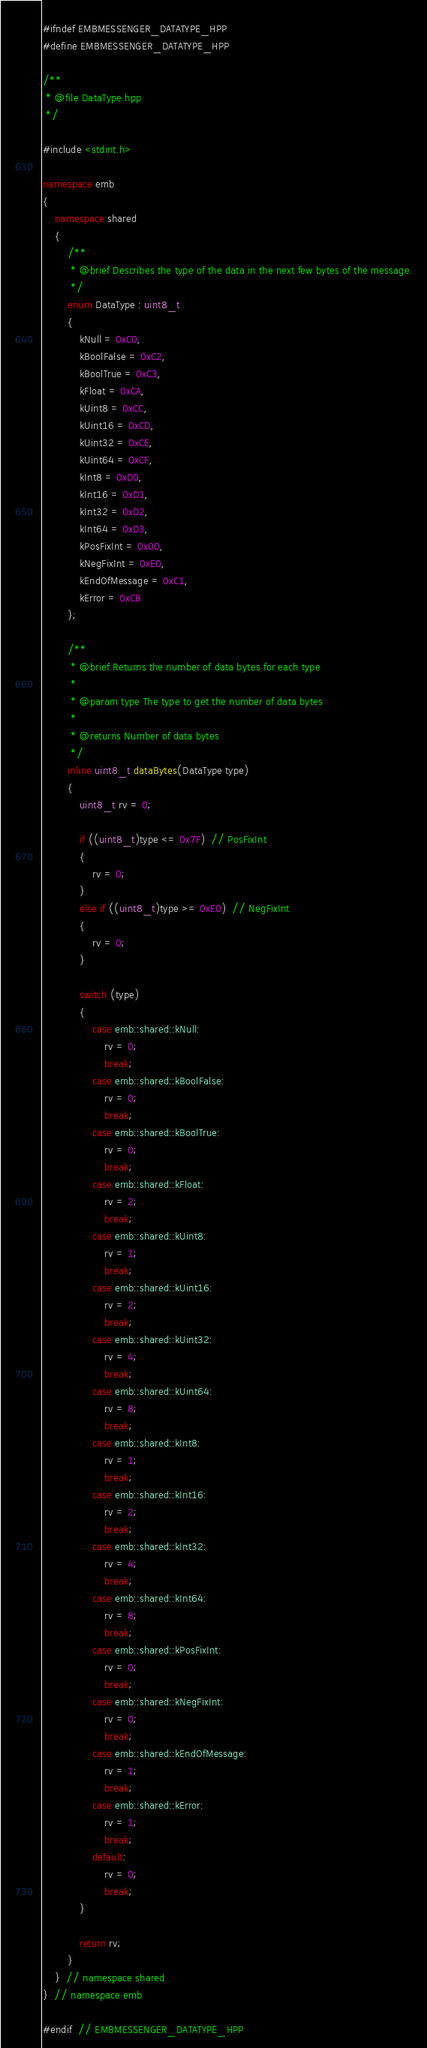<code> <loc_0><loc_0><loc_500><loc_500><_C++_>#ifndef EMBMESSENGER_DATATYPE_HPP
#define EMBMESSENGER_DATATYPE_HPP

/**
 * @file DataType.hpp
 */

#include <stdint.h>

namespace emb
{
    namespace shared
    {
        /**
         * @brief Describes the type of the data in the next few bytes of the message.
         */
        enum DataType : uint8_t
        {
            kNull = 0xC0,
            kBoolFalse = 0xC2,
            kBoolTrue = 0xC3,
            kFloat = 0xCA,
            kUint8 = 0xCC,
            kUint16 = 0xCD,
            kUint32 = 0xCE,
            kUint64 = 0xCF,
            kInt8 = 0xD0,
            kInt16 = 0xD1,
            kInt32 = 0xD2,
            kInt64 = 0xD3,
            kPosFixInt = 0x00,
            kNegFixInt = 0xE0,
            kEndOfMessage = 0xC1,
            kError = 0xCB
        };

        /**
         * @brief Returns the number of data bytes for each type
         *
         * @param type The type to get the number of data bytes
         *
         * @returns Number of data bytes
         */
        inline uint8_t dataBytes(DataType type)
        {
            uint8_t rv = 0;

            if ((uint8_t)type <= 0x7F)  // PosFixInt
            {
                rv = 0;
            }
            else if ((uint8_t)type >= 0xE0)  // NegFixInt
            {
                rv = 0;
            }

            switch (type)
            {
                case emb::shared::kNull:
                    rv = 0;
                    break;
                case emb::shared::kBoolFalse:
                    rv = 0;
                    break;
                case emb::shared::kBoolTrue:
                    rv = 0;
                    break;
                case emb::shared::kFloat:
                    rv = 2;
                    break;
                case emb::shared::kUint8:
                    rv = 1;
                    break;
                case emb::shared::kUint16:
                    rv = 2;
                    break;
                case emb::shared::kUint32:
                    rv = 4;
                    break;
                case emb::shared::kUint64:
                    rv = 8;
                    break;
                case emb::shared::kInt8:
                    rv = 1;
                    break;
                case emb::shared::kInt16:
                    rv = 2;
                    break;
                case emb::shared::kInt32:
                    rv = 4;
                    break;
                case emb::shared::kInt64:
                    rv = 8;
                    break;
                case emb::shared::kPosFixInt:
                    rv = 0;
                    break;
                case emb::shared::kNegFixInt:
                    rv = 0;
                    break;
                case emb::shared::kEndOfMessage:
                    rv = 1;
                    break;
                case emb::shared::kError:
                    rv = 1;
                    break;
                default:
                    rv = 0;
                    break;
            }

            return rv;
        }
    }  // namespace shared
}  // namespace emb

#endif  // EMBMESSENGER_DATATYPE_HPP</code> 